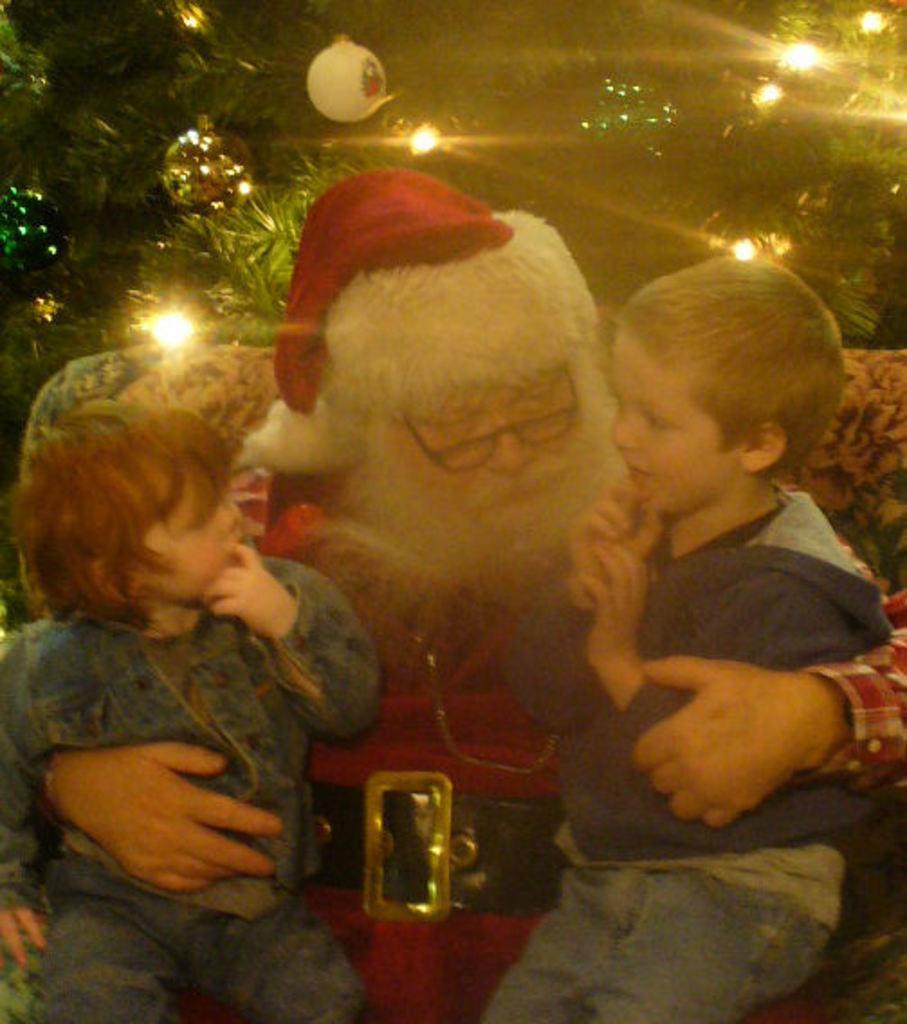How would you summarize this image in a sentence or two? In this image we can see one man holding two children in his arms. 